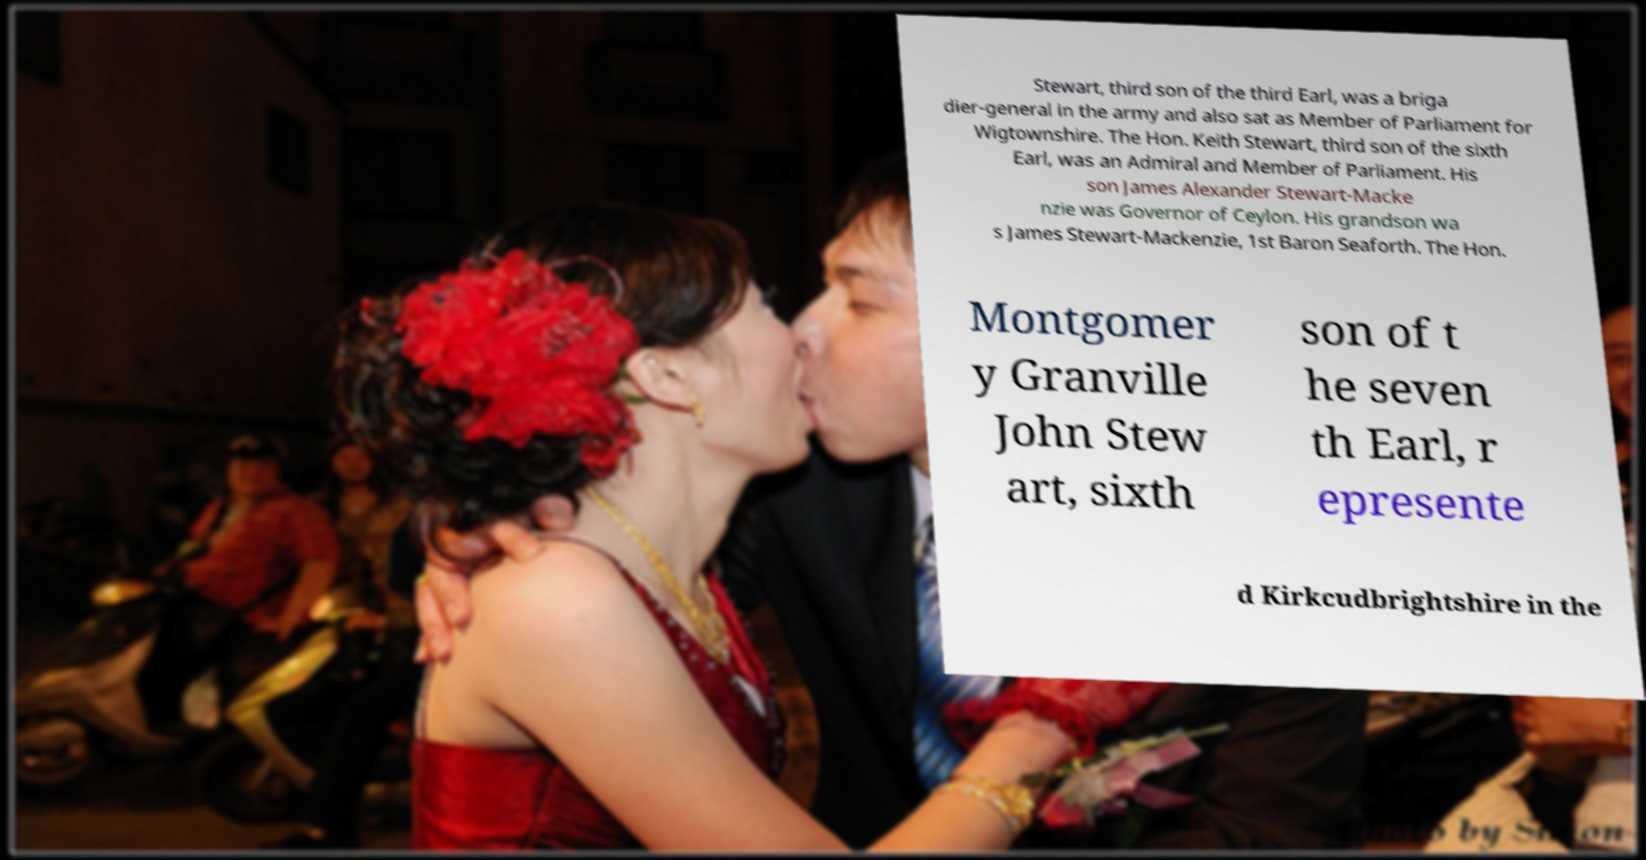Could you extract and type out the text from this image? Stewart, third son of the third Earl, was a briga dier-general in the army and also sat as Member of Parliament for Wigtownshire. The Hon. Keith Stewart, third son of the sixth Earl, was an Admiral and Member of Parliament. His son James Alexander Stewart-Macke nzie was Governor of Ceylon. His grandson wa s James Stewart-Mackenzie, 1st Baron Seaforth. The Hon. Montgomer y Granville John Stew art, sixth son of t he seven th Earl, r epresente d Kirkcudbrightshire in the 